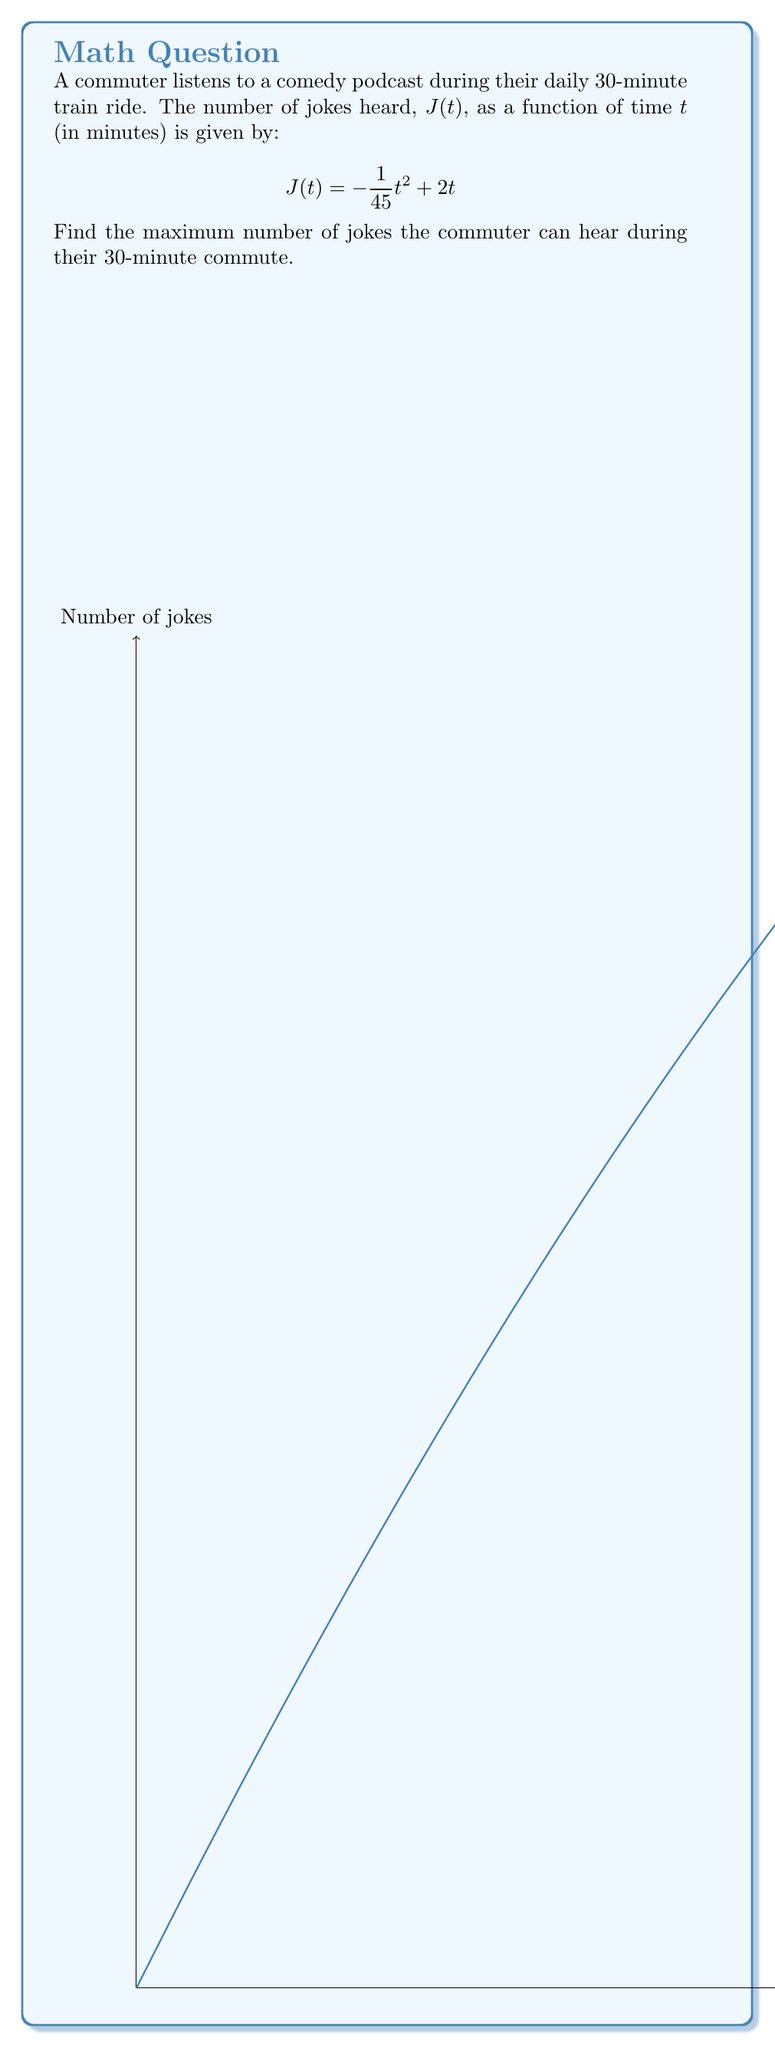Could you help me with this problem? To find the maximum number of jokes, we need to follow these steps:

1) First, we need to find the critical points of the function $J(t)$ by taking its derivative and setting it equal to zero:

   $$J'(t) = -\frac{2}{45}t + 2$$
   $$-\frac{2}{45}t + 2 = 0$$
   $$-\frac{2}{45}t = -2$$
   $$t = 45$$

2) The critical point $t = 45$ is outside our domain of $[0, 30]$, so we need to check the endpoints of our interval.

3) Evaluate $J(t)$ at $t = 0$ and $t = 30$:

   $$J(0) = -\frac{1}{45}(0)^2 + 2(0) = 0$$
   $$J(30) = -\frac{1}{45}(30)^2 + 2(30) = -20 + 60 = 40$$

4) The maximum value occurs at $t = 30$ minutes, which corresponds to 40 jokes.

Therefore, the maximum number of jokes the commuter can hear during their 30-minute commute is 40.
Answer: 40 jokes 